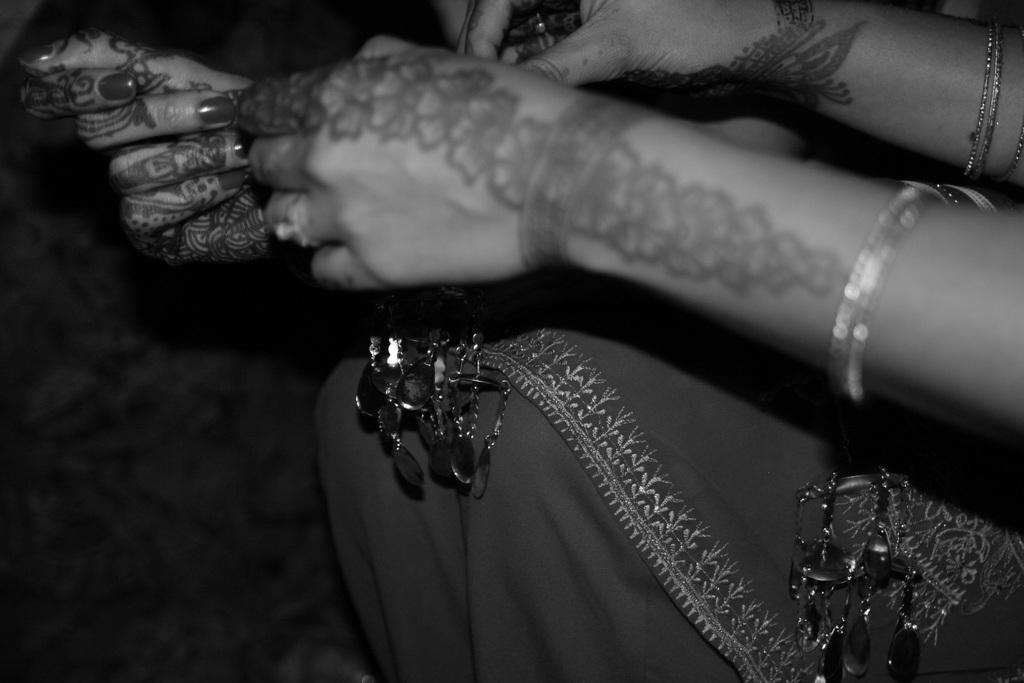What body parts are visible in the image? There are hands visible in the image. What type of jewelry can be seen on the hands? There are bangles in the image. Can you describe the background of the image? The background of the image is dark. What type of club is being held by the hands in the image? There is no club present in the image; only hands and bangles are visible. 